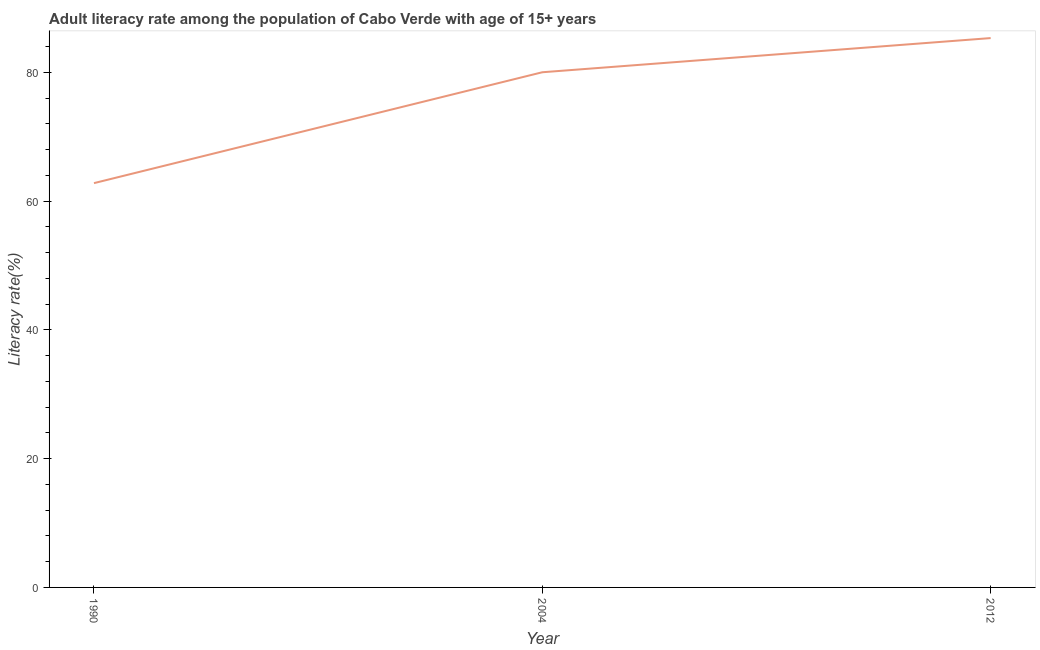What is the adult literacy rate in 2012?
Ensure brevity in your answer.  85.33. Across all years, what is the maximum adult literacy rate?
Provide a short and direct response. 85.33. Across all years, what is the minimum adult literacy rate?
Your response must be concise. 62.8. In which year was the adult literacy rate maximum?
Your answer should be very brief. 2012. What is the sum of the adult literacy rate?
Make the answer very short. 228.14. What is the difference between the adult literacy rate in 2004 and 2012?
Your answer should be very brief. -5.31. What is the average adult literacy rate per year?
Keep it short and to the point. 76.05. What is the median adult literacy rate?
Offer a terse response. 80.02. In how many years, is the adult literacy rate greater than 64 %?
Your answer should be compact. 2. Do a majority of the years between 1990 and 2004 (inclusive) have adult literacy rate greater than 12 %?
Your answer should be compact. Yes. What is the ratio of the adult literacy rate in 1990 to that in 2004?
Give a very brief answer. 0.78. Is the adult literacy rate in 1990 less than that in 2004?
Your response must be concise. Yes. What is the difference between the highest and the second highest adult literacy rate?
Give a very brief answer. 5.31. What is the difference between the highest and the lowest adult literacy rate?
Offer a very short reply. 22.53. How many years are there in the graph?
Ensure brevity in your answer.  3. Are the values on the major ticks of Y-axis written in scientific E-notation?
Provide a succinct answer. No. Does the graph contain any zero values?
Your answer should be compact. No. What is the title of the graph?
Make the answer very short. Adult literacy rate among the population of Cabo Verde with age of 15+ years. What is the label or title of the Y-axis?
Your response must be concise. Literacy rate(%). What is the Literacy rate(%) in 1990?
Provide a short and direct response. 62.8. What is the Literacy rate(%) in 2004?
Provide a short and direct response. 80.02. What is the Literacy rate(%) of 2012?
Keep it short and to the point. 85.33. What is the difference between the Literacy rate(%) in 1990 and 2004?
Offer a very short reply. -17.22. What is the difference between the Literacy rate(%) in 1990 and 2012?
Keep it short and to the point. -22.53. What is the difference between the Literacy rate(%) in 2004 and 2012?
Your response must be concise. -5.31. What is the ratio of the Literacy rate(%) in 1990 to that in 2004?
Provide a succinct answer. 0.79. What is the ratio of the Literacy rate(%) in 1990 to that in 2012?
Keep it short and to the point. 0.74. What is the ratio of the Literacy rate(%) in 2004 to that in 2012?
Make the answer very short. 0.94. 